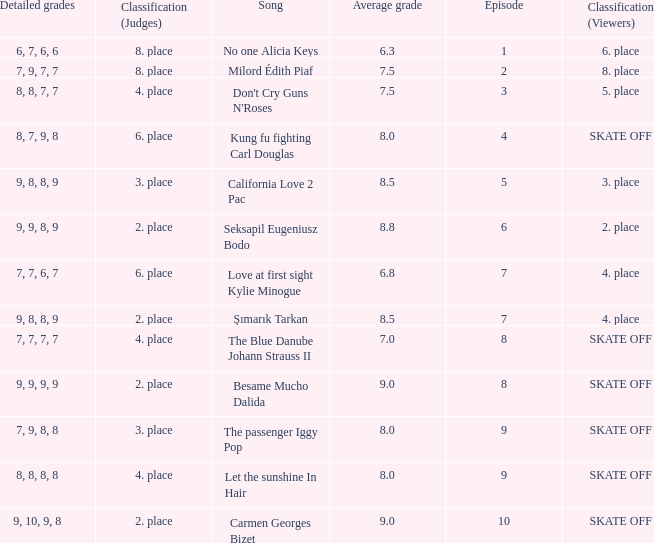Name the classification for 9, 9, 8, 9 2. place. 